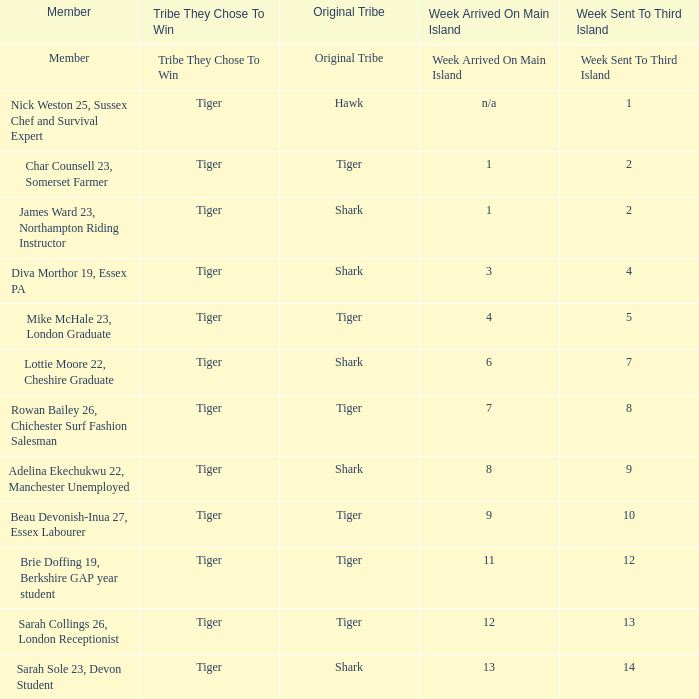Would you be able to parse every entry in this table? {'header': ['Member', 'Tribe They Chose To Win', 'Original Tribe', 'Week Arrived On Main Island', 'Week Sent To Third Island'], 'rows': [['Member', 'Tribe They Chose To Win', 'Original Tribe', 'Week Arrived On Main Island', 'Week Sent To Third Island'], ['Nick Weston 25, Sussex Chef and Survival Expert', 'Tiger', 'Hawk', 'n/a', '1'], ['Char Counsell 23, Somerset Farmer', 'Tiger', 'Tiger', '1', '2'], ['James Ward 23, Northampton Riding Instructor', 'Tiger', 'Shark', '1', '2'], ['Diva Morthor 19, Essex PA', 'Tiger', 'Shark', '3', '4'], ['Mike McHale 23, London Graduate', 'Tiger', 'Tiger', '4', '5'], ['Lottie Moore 22, Cheshire Graduate', 'Tiger', 'Shark', '6', '7'], ['Rowan Bailey 26, Chichester Surf Fashion Salesman', 'Tiger', 'Tiger', '7', '8'], ['Adelina Ekechukwu 22, Manchester Unemployed', 'Tiger', 'Shark', '8', '9'], ['Beau Devonish-Inua 27, Essex Labourer', 'Tiger', 'Tiger', '9', '10'], ['Brie Doffing 19, Berkshire GAP year student', 'Tiger', 'Tiger', '11', '12'], ['Sarah Collings 26, London Receptionist', 'Tiger', 'Tiger', '12', '13'], ['Sarah Sole 23, Devon Student', 'Tiger', 'Shark', '13', '14']]} How many members arrived on the main island in week 4? 1.0. 